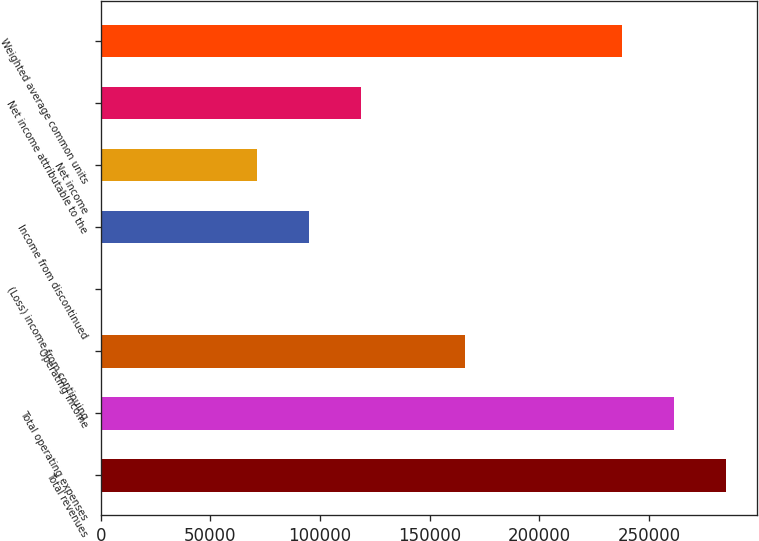Convert chart. <chart><loc_0><loc_0><loc_500><loc_500><bar_chart><fcel>Total revenues<fcel>Total operating expenses<fcel>Operating income<fcel>(Loss) income from continuing<fcel>Income from discontinued<fcel>Net income<fcel>Net income attributable to the<fcel>Weighted average common units<nl><fcel>285005<fcel>261254<fcel>166253<fcel>0.01<fcel>95001.6<fcel>71251.2<fcel>118752<fcel>237504<nl></chart> 